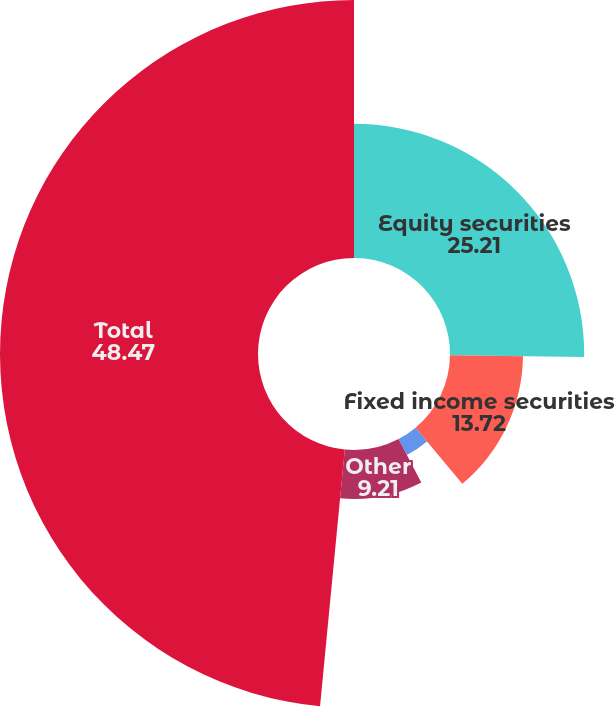Convert chart. <chart><loc_0><loc_0><loc_500><loc_500><pie_chart><fcel>Equity securities<fcel>Fixed income securities<fcel>Real estate<fcel>Other<fcel>Total<nl><fcel>25.21%<fcel>13.72%<fcel>3.39%<fcel>9.21%<fcel>48.47%<nl></chart> 